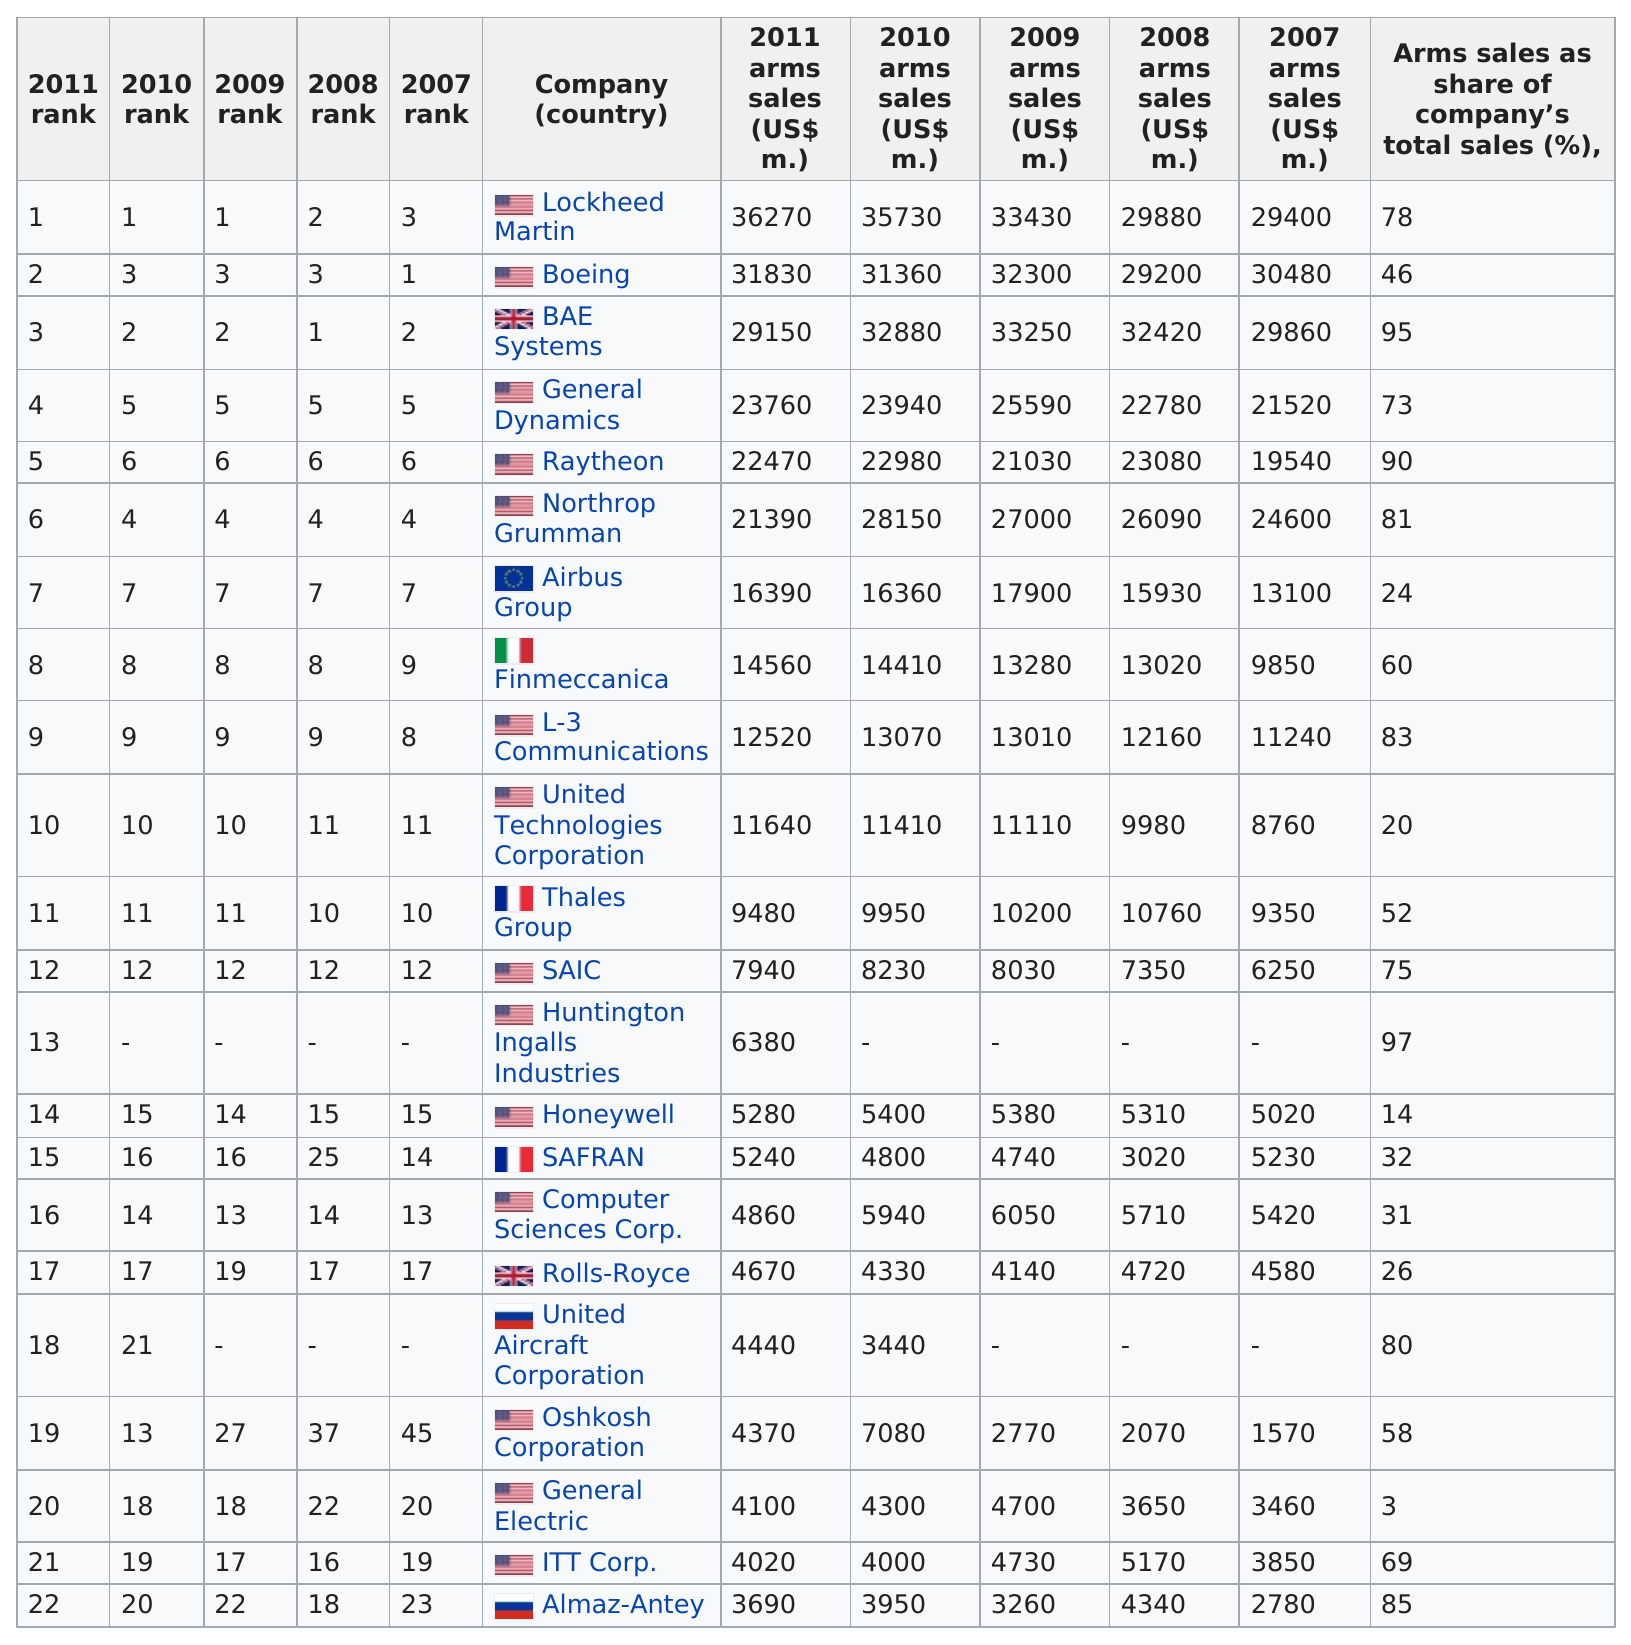Draw attention to some important aspects in this diagram. In 2009, Lockheed Martin had the highest arms sales among all companies. According to the most recent data available, there are approximately 14 companies under the United States. In 2010, United Aircraft Corporation had the least amount of sales among all companies. In 2011, Lockheed Martin had the largest amount of sales among all companies. The United States of America is the first listed country. 